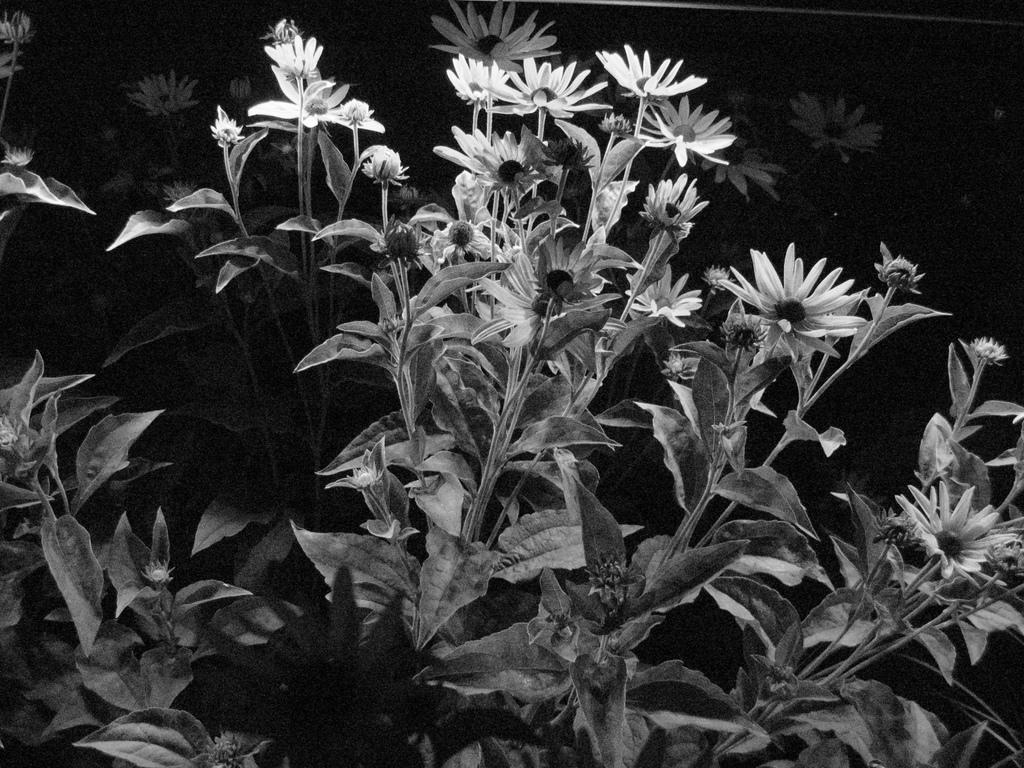What type of plants can be seen in the image? There are flower plants in the image. What is the color scheme of the image? The image is black and white in color. What invention is being reported on the news in the image? There is no news or invention present in the image; it only features flower plants in a black and white color scheme. 